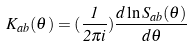Convert formula to latex. <formula><loc_0><loc_0><loc_500><loc_500>K _ { a b } ( \theta ) = ( \frac { 1 } { 2 \pi i } ) \frac { d \ln S _ { a b } ( \theta ) } { d \theta }</formula> 